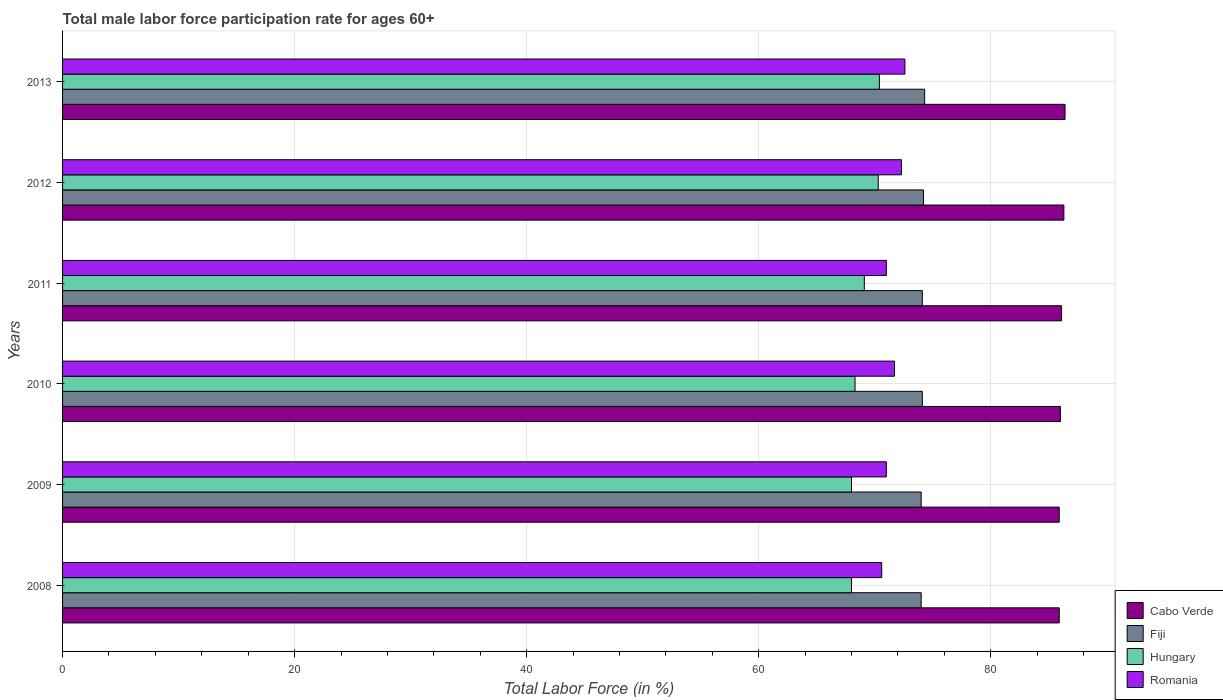How many groups of bars are there?
Make the answer very short. 6. Are the number of bars per tick equal to the number of legend labels?
Offer a terse response. Yes. Are the number of bars on each tick of the Y-axis equal?
Provide a short and direct response. Yes. How many bars are there on the 1st tick from the bottom?
Provide a short and direct response. 4. In how many cases, is the number of bars for a given year not equal to the number of legend labels?
Offer a very short reply. 0. What is the male labor force participation rate in Hungary in 2008?
Provide a succinct answer. 68. Across all years, what is the maximum male labor force participation rate in Fiji?
Provide a succinct answer. 74.3. In which year was the male labor force participation rate in Cabo Verde maximum?
Make the answer very short. 2013. What is the total male labor force participation rate in Cabo Verde in the graph?
Ensure brevity in your answer.  516.6. What is the difference between the male labor force participation rate in Fiji in 2009 and that in 2012?
Make the answer very short. -0.2. What is the difference between the male labor force participation rate in Romania in 2008 and the male labor force participation rate in Cabo Verde in 2013?
Provide a short and direct response. -15.8. What is the average male labor force participation rate in Cabo Verde per year?
Make the answer very short. 86.1. In the year 2010, what is the difference between the male labor force participation rate in Hungary and male labor force participation rate in Fiji?
Keep it short and to the point. -5.8. In how many years, is the male labor force participation rate in Cabo Verde greater than 16 %?
Provide a succinct answer. 6. What is the ratio of the male labor force participation rate in Hungary in 2009 to that in 2013?
Offer a terse response. 0.97. Is the difference between the male labor force participation rate in Hungary in 2010 and 2011 greater than the difference between the male labor force participation rate in Fiji in 2010 and 2011?
Give a very brief answer. No. What is the difference between the highest and the second highest male labor force participation rate in Cabo Verde?
Your answer should be very brief. 0.1. What does the 4th bar from the top in 2009 represents?
Your response must be concise. Cabo Verde. What does the 2nd bar from the bottom in 2010 represents?
Provide a short and direct response. Fiji. Is it the case that in every year, the sum of the male labor force participation rate in Romania and male labor force participation rate in Hungary is greater than the male labor force participation rate in Fiji?
Your response must be concise. Yes. How many bars are there?
Provide a succinct answer. 24. Are all the bars in the graph horizontal?
Your response must be concise. Yes. How many years are there in the graph?
Your answer should be very brief. 6. Are the values on the major ticks of X-axis written in scientific E-notation?
Provide a succinct answer. No. Does the graph contain grids?
Provide a succinct answer. Yes. Where does the legend appear in the graph?
Provide a succinct answer. Bottom right. How many legend labels are there?
Make the answer very short. 4. How are the legend labels stacked?
Your response must be concise. Vertical. What is the title of the graph?
Offer a terse response. Total male labor force participation rate for ages 60+. What is the label or title of the Y-axis?
Offer a very short reply. Years. What is the Total Labor Force (in %) of Cabo Verde in 2008?
Give a very brief answer. 85.9. What is the Total Labor Force (in %) in Fiji in 2008?
Offer a terse response. 74. What is the Total Labor Force (in %) in Romania in 2008?
Make the answer very short. 70.6. What is the Total Labor Force (in %) in Cabo Verde in 2009?
Give a very brief answer. 85.9. What is the Total Labor Force (in %) in Hungary in 2009?
Ensure brevity in your answer.  68. What is the Total Labor Force (in %) in Romania in 2009?
Your answer should be very brief. 71. What is the Total Labor Force (in %) of Fiji in 2010?
Provide a succinct answer. 74.1. What is the Total Labor Force (in %) of Hungary in 2010?
Give a very brief answer. 68.3. What is the Total Labor Force (in %) of Romania in 2010?
Your answer should be very brief. 71.7. What is the Total Labor Force (in %) in Cabo Verde in 2011?
Provide a short and direct response. 86.1. What is the Total Labor Force (in %) of Fiji in 2011?
Your answer should be very brief. 74.1. What is the Total Labor Force (in %) in Hungary in 2011?
Offer a very short reply. 69.1. What is the Total Labor Force (in %) in Romania in 2011?
Your response must be concise. 71. What is the Total Labor Force (in %) in Cabo Verde in 2012?
Provide a succinct answer. 86.3. What is the Total Labor Force (in %) in Fiji in 2012?
Provide a succinct answer. 74.2. What is the Total Labor Force (in %) in Hungary in 2012?
Keep it short and to the point. 70.3. What is the Total Labor Force (in %) of Romania in 2012?
Your answer should be compact. 72.3. What is the Total Labor Force (in %) in Cabo Verde in 2013?
Your response must be concise. 86.4. What is the Total Labor Force (in %) in Fiji in 2013?
Keep it short and to the point. 74.3. What is the Total Labor Force (in %) of Hungary in 2013?
Offer a very short reply. 70.4. What is the Total Labor Force (in %) of Romania in 2013?
Keep it short and to the point. 72.6. Across all years, what is the maximum Total Labor Force (in %) of Cabo Verde?
Provide a succinct answer. 86.4. Across all years, what is the maximum Total Labor Force (in %) in Fiji?
Offer a terse response. 74.3. Across all years, what is the maximum Total Labor Force (in %) in Hungary?
Offer a terse response. 70.4. Across all years, what is the maximum Total Labor Force (in %) of Romania?
Your response must be concise. 72.6. Across all years, what is the minimum Total Labor Force (in %) of Cabo Verde?
Offer a terse response. 85.9. Across all years, what is the minimum Total Labor Force (in %) in Romania?
Give a very brief answer. 70.6. What is the total Total Labor Force (in %) of Cabo Verde in the graph?
Keep it short and to the point. 516.6. What is the total Total Labor Force (in %) in Fiji in the graph?
Make the answer very short. 444.7. What is the total Total Labor Force (in %) in Hungary in the graph?
Provide a succinct answer. 414.1. What is the total Total Labor Force (in %) of Romania in the graph?
Your answer should be very brief. 429.2. What is the difference between the Total Labor Force (in %) in Cabo Verde in 2008 and that in 2009?
Offer a terse response. 0. What is the difference between the Total Labor Force (in %) in Hungary in 2008 and that in 2009?
Make the answer very short. 0. What is the difference between the Total Labor Force (in %) in Romania in 2008 and that in 2009?
Your response must be concise. -0.4. What is the difference between the Total Labor Force (in %) in Fiji in 2008 and that in 2010?
Your response must be concise. -0.1. What is the difference between the Total Labor Force (in %) of Hungary in 2008 and that in 2010?
Ensure brevity in your answer.  -0.3. What is the difference between the Total Labor Force (in %) of Romania in 2008 and that in 2011?
Keep it short and to the point. -0.4. What is the difference between the Total Labor Force (in %) in Cabo Verde in 2008 and that in 2012?
Your response must be concise. -0.4. What is the difference between the Total Labor Force (in %) in Fiji in 2008 and that in 2012?
Provide a succinct answer. -0.2. What is the difference between the Total Labor Force (in %) of Hungary in 2008 and that in 2012?
Your answer should be compact. -2.3. What is the difference between the Total Labor Force (in %) in Romania in 2008 and that in 2012?
Your response must be concise. -1.7. What is the difference between the Total Labor Force (in %) in Hungary in 2008 and that in 2013?
Give a very brief answer. -2.4. What is the difference between the Total Labor Force (in %) of Romania in 2008 and that in 2013?
Offer a very short reply. -2. What is the difference between the Total Labor Force (in %) of Romania in 2009 and that in 2010?
Your answer should be very brief. -0.7. What is the difference between the Total Labor Force (in %) in Cabo Verde in 2009 and that in 2011?
Provide a succinct answer. -0.2. What is the difference between the Total Labor Force (in %) of Fiji in 2009 and that in 2011?
Keep it short and to the point. -0.1. What is the difference between the Total Labor Force (in %) of Hungary in 2009 and that in 2011?
Provide a short and direct response. -1.1. What is the difference between the Total Labor Force (in %) in Hungary in 2009 and that in 2012?
Provide a short and direct response. -2.3. What is the difference between the Total Labor Force (in %) of Hungary in 2009 and that in 2013?
Your response must be concise. -2.4. What is the difference between the Total Labor Force (in %) of Romania in 2009 and that in 2013?
Your answer should be compact. -1.6. What is the difference between the Total Labor Force (in %) of Cabo Verde in 2010 and that in 2011?
Keep it short and to the point. -0.1. What is the difference between the Total Labor Force (in %) of Fiji in 2010 and that in 2011?
Keep it short and to the point. 0. What is the difference between the Total Labor Force (in %) of Hungary in 2010 and that in 2011?
Offer a terse response. -0.8. What is the difference between the Total Labor Force (in %) of Romania in 2010 and that in 2011?
Offer a terse response. 0.7. What is the difference between the Total Labor Force (in %) in Cabo Verde in 2010 and that in 2012?
Your response must be concise. -0.3. What is the difference between the Total Labor Force (in %) of Hungary in 2010 and that in 2012?
Provide a short and direct response. -2. What is the difference between the Total Labor Force (in %) of Hungary in 2010 and that in 2013?
Ensure brevity in your answer.  -2.1. What is the difference between the Total Labor Force (in %) in Romania in 2010 and that in 2013?
Your answer should be compact. -0.9. What is the difference between the Total Labor Force (in %) in Cabo Verde in 2011 and that in 2012?
Your answer should be compact. -0.2. What is the difference between the Total Labor Force (in %) in Fiji in 2011 and that in 2012?
Make the answer very short. -0.1. What is the difference between the Total Labor Force (in %) of Hungary in 2011 and that in 2012?
Your response must be concise. -1.2. What is the difference between the Total Labor Force (in %) in Romania in 2011 and that in 2012?
Provide a short and direct response. -1.3. What is the difference between the Total Labor Force (in %) in Cabo Verde in 2011 and that in 2013?
Keep it short and to the point. -0.3. What is the difference between the Total Labor Force (in %) in Fiji in 2011 and that in 2013?
Offer a terse response. -0.2. What is the difference between the Total Labor Force (in %) in Hungary in 2011 and that in 2013?
Ensure brevity in your answer.  -1.3. What is the difference between the Total Labor Force (in %) of Cabo Verde in 2012 and that in 2013?
Offer a very short reply. -0.1. What is the difference between the Total Labor Force (in %) in Fiji in 2012 and that in 2013?
Keep it short and to the point. -0.1. What is the difference between the Total Labor Force (in %) of Cabo Verde in 2008 and the Total Labor Force (in %) of Romania in 2009?
Provide a succinct answer. 14.9. What is the difference between the Total Labor Force (in %) of Fiji in 2008 and the Total Labor Force (in %) of Romania in 2009?
Your response must be concise. 3. What is the difference between the Total Labor Force (in %) of Cabo Verde in 2008 and the Total Labor Force (in %) of Fiji in 2010?
Your response must be concise. 11.8. What is the difference between the Total Labor Force (in %) of Cabo Verde in 2008 and the Total Labor Force (in %) of Hungary in 2010?
Give a very brief answer. 17.6. What is the difference between the Total Labor Force (in %) in Cabo Verde in 2008 and the Total Labor Force (in %) in Romania in 2010?
Your answer should be very brief. 14.2. What is the difference between the Total Labor Force (in %) in Fiji in 2008 and the Total Labor Force (in %) in Romania in 2010?
Your answer should be very brief. 2.3. What is the difference between the Total Labor Force (in %) of Cabo Verde in 2008 and the Total Labor Force (in %) of Fiji in 2011?
Your response must be concise. 11.8. What is the difference between the Total Labor Force (in %) of Cabo Verde in 2008 and the Total Labor Force (in %) of Fiji in 2012?
Your answer should be very brief. 11.7. What is the difference between the Total Labor Force (in %) of Fiji in 2008 and the Total Labor Force (in %) of Hungary in 2012?
Offer a very short reply. 3.7. What is the difference between the Total Labor Force (in %) in Hungary in 2008 and the Total Labor Force (in %) in Romania in 2012?
Give a very brief answer. -4.3. What is the difference between the Total Labor Force (in %) of Cabo Verde in 2008 and the Total Labor Force (in %) of Hungary in 2013?
Give a very brief answer. 15.5. What is the difference between the Total Labor Force (in %) in Cabo Verde in 2008 and the Total Labor Force (in %) in Romania in 2013?
Your response must be concise. 13.3. What is the difference between the Total Labor Force (in %) of Fiji in 2008 and the Total Labor Force (in %) of Hungary in 2013?
Provide a succinct answer. 3.6. What is the difference between the Total Labor Force (in %) in Cabo Verde in 2009 and the Total Labor Force (in %) in Hungary in 2010?
Your answer should be compact. 17.6. What is the difference between the Total Labor Force (in %) of Cabo Verde in 2009 and the Total Labor Force (in %) of Romania in 2010?
Your answer should be compact. 14.2. What is the difference between the Total Labor Force (in %) in Cabo Verde in 2009 and the Total Labor Force (in %) in Fiji in 2011?
Give a very brief answer. 11.8. What is the difference between the Total Labor Force (in %) in Cabo Verde in 2009 and the Total Labor Force (in %) in Hungary in 2011?
Your answer should be compact. 16.8. What is the difference between the Total Labor Force (in %) in Fiji in 2009 and the Total Labor Force (in %) in Hungary in 2011?
Your answer should be very brief. 4.9. What is the difference between the Total Labor Force (in %) in Fiji in 2009 and the Total Labor Force (in %) in Romania in 2011?
Make the answer very short. 3. What is the difference between the Total Labor Force (in %) of Cabo Verde in 2009 and the Total Labor Force (in %) of Hungary in 2012?
Offer a terse response. 15.6. What is the difference between the Total Labor Force (in %) in Cabo Verde in 2009 and the Total Labor Force (in %) in Romania in 2012?
Make the answer very short. 13.6. What is the difference between the Total Labor Force (in %) of Fiji in 2009 and the Total Labor Force (in %) of Hungary in 2012?
Your response must be concise. 3.7. What is the difference between the Total Labor Force (in %) of Fiji in 2009 and the Total Labor Force (in %) of Romania in 2012?
Give a very brief answer. 1.7. What is the difference between the Total Labor Force (in %) in Cabo Verde in 2009 and the Total Labor Force (in %) in Fiji in 2013?
Provide a short and direct response. 11.6. What is the difference between the Total Labor Force (in %) of Cabo Verde in 2009 and the Total Labor Force (in %) of Hungary in 2013?
Provide a short and direct response. 15.5. What is the difference between the Total Labor Force (in %) in Fiji in 2009 and the Total Labor Force (in %) in Hungary in 2013?
Make the answer very short. 3.6. What is the difference between the Total Labor Force (in %) of Fiji in 2009 and the Total Labor Force (in %) of Romania in 2013?
Your answer should be very brief. 1.4. What is the difference between the Total Labor Force (in %) of Hungary in 2009 and the Total Labor Force (in %) of Romania in 2013?
Offer a terse response. -4.6. What is the difference between the Total Labor Force (in %) in Cabo Verde in 2010 and the Total Labor Force (in %) in Fiji in 2011?
Ensure brevity in your answer.  11.9. What is the difference between the Total Labor Force (in %) of Cabo Verde in 2010 and the Total Labor Force (in %) of Hungary in 2011?
Keep it short and to the point. 16.9. What is the difference between the Total Labor Force (in %) of Fiji in 2010 and the Total Labor Force (in %) of Romania in 2011?
Offer a terse response. 3.1. What is the difference between the Total Labor Force (in %) of Hungary in 2010 and the Total Labor Force (in %) of Romania in 2011?
Offer a very short reply. -2.7. What is the difference between the Total Labor Force (in %) in Cabo Verde in 2010 and the Total Labor Force (in %) in Fiji in 2012?
Keep it short and to the point. 11.8. What is the difference between the Total Labor Force (in %) of Fiji in 2010 and the Total Labor Force (in %) of Romania in 2012?
Make the answer very short. 1.8. What is the difference between the Total Labor Force (in %) of Hungary in 2010 and the Total Labor Force (in %) of Romania in 2013?
Offer a very short reply. -4.3. What is the difference between the Total Labor Force (in %) in Fiji in 2011 and the Total Labor Force (in %) in Hungary in 2012?
Make the answer very short. 3.8. What is the difference between the Total Labor Force (in %) of Fiji in 2011 and the Total Labor Force (in %) of Romania in 2012?
Your answer should be very brief. 1.8. What is the difference between the Total Labor Force (in %) of Hungary in 2011 and the Total Labor Force (in %) of Romania in 2012?
Give a very brief answer. -3.2. What is the difference between the Total Labor Force (in %) in Cabo Verde in 2011 and the Total Labor Force (in %) in Fiji in 2013?
Your answer should be compact. 11.8. What is the difference between the Total Labor Force (in %) of Cabo Verde in 2011 and the Total Labor Force (in %) of Romania in 2013?
Your answer should be compact. 13.5. What is the difference between the Total Labor Force (in %) of Cabo Verde in 2012 and the Total Labor Force (in %) of Fiji in 2013?
Offer a very short reply. 12. What is the difference between the Total Labor Force (in %) of Cabo Verde in 2012 and the Total Labor Force (in %) of Hungary in 2013?
Your answer should be compact. 15.9. What is the difference between the Total Labor Force (in %) of Fiji in 2012 and the Total Labor Force (in %) of Hungary in 2013?
Offer a very short reply. 3.8. What is the difference between the Total Labor Force (in %) of Fiji in 2012 and the Total Labor Force (in %) of Romania in 2013?
Make the answer very short. 1.6. What is the average Total Labor Force (in %) of Cabo Verde per year?
Your answer should be very brief. 86.1. What is the average Total Labor Force (in %) of Fiji per year?
Offer a terse response. 74.12. What is the average Total Labor Force (in %) of Hungary per year?
Your answer should be very brief. 69.02. What is the average Total Labor Force (in %) in Romania per year?
Ensure brevity in your answer.  71.53. In the year 2008, what is the difference between the Total Labor Force (in %) in Cabo Verde and Total Labor Force (in %) in Hungary?
Provide a short and direct response. 17.9. In the year 2008, what is the difference between the Total Labor Force (in %) of Fiji and Total Labor Force (in %) of Romania?
Your response must be concise. 3.4. In the year 2009, what is the difference between the Total Labor Force (in %) of Cabo Verde and Total Labor Force (in %) of Fiji?
Give a very brief answer. 11.9. In the year 2009, what is the difference between the Total Labor Force (in %) of Cabo Verde and Total Labor Force (in %) of Hungary?
Offer a terse response. 17.9. In the year 2009, what is the difference between the Total Labor Force (in %) in Hungary and Total Labor Force (in %) in Romania?
Offer a terse response. -3. In the year 2010, what is the difference between the Total Labor Force (in %) of Fiji and Total Labor Force (in %) of Hungary?
Give a very brief answer. 5.8. In the year 2010, what is the difference between the Total Labor Force (in %) of Fiji and Total Labor Force (in %) of Romania?
Your answer should be very brief. 2.4. In the year 2011, what is the difference between the Total Labor Force (in %) of Cabo Verde and Total Labor Force (in %) of Hungary?
Your answer should be compact. 17. In the year 2011, what is the difference between the Total Labor Force (in %) of Cabo Verde and Total Labor Force (in %) of Romania?
Keep it short and to the point. 15.1. In the year 2011, what is the difference between the Total Labor Force (in %) of Fiji and Total Labor Force (in %) of Hungary?
Make the answer very short. 5. In the year 2011, what is the difference between the Total Labor Force (in %) in Hungary and Total Labor Force (in %) in Romania?
Your answer should be very brief. -1.9. In the year 2012, what is the difference between the Total Labor Force (in %) in Cabo Verde and Total Labor Force (in %) in Fiji?
Your response must be concise. 12.1. In the year 2012, what is the difference between the Total Labor Force (in %) in Cabo Verde and Total Labor Force (in %) in Romania?
Make the answer very short. 14. In the year 2012, what is the difference between the Total Labor Force (in %) of Fiji and Total Labor Force (in %) of Hungary?
Give a very brief answer. 3.9. In the year 2012, what is the difference between the Total Labor Force (in %) of Fiji and Total Labor Force (in %) of Romania?
Give a very brief answer. 1.9. In the year 2012, what is the difference between the Total Labor Force (in %) in Hungary and Total Labor Force (in %) in Romania?
Provide a succinct answer. -2. In the year 2013, what is the difference between the Total Labor Force (in %) of Cabo Verde and Total Labor Force (in %) of Romania?
Make the answer very short. 13.8. In the year 2013, what is the difference between the Total Labor Force (in %) of Fiji and Total Labor Force (in %) of Hungary?
Make the answer very short. 3.9. In the year 2013, what is the difference between the Total Labor Force (in %) of Fiji and Total Labor Force (in %) of Romania?
Offer a terse response. 1.7. What is the ratio of the Total Labor Force (in %) in Cabo Verde in 2008 to that in 2009?
Your answer should be very brief. 1. What is the ratio of the Total Labor Force (in %) of Fiji in 2008 to that in 2009?
Give a very brief answer. 1. What is the ratio of the Total Labor Force (in %) of Romania in 2008 to that in 2009?
Offer a terse response. 0.99. What is the ratio of the Total Labor Force (in %) in Cabo Verde in 2008 to that in 2010?
Your answer should be compact. 1. What is the ratio of the Total Labor Force (in %) in Fiji in 2008 to that in 2010?
Provide a succinct answer. 1. What is the ratio of the Total Labor Force (in %) of Romania in 2008 to that in 2010?
Provide a succinct answer. 0.98. What is the ratio of the Total Labor Force (in %) in Cabo Verde in 2008 to that in 2011?
Your answer should be very brief. 1. What is the ratio of the Total Labor Force (in %) of Fiji in 2008 to that in 2011?
Give a very brief answer. 1. What is the ratio of the Total Labor Force (in %) in Hungary in 2008 to that in 2011?
Your answer should be compact. 0.98. What is the ratio of the Total Labor Force (in %) of Romania in 2008 to that in 2011?
Offer a terse response. 0.99. What is the ratio of the Total Labor Force (in %) in Hungary in 2008 to that in 2012?
Your answer should be compact. 0.97. What is the ratio of the Total Labor Force (in %) in Romania in 2008 to that in 2012?
Keep it short and to the point. 0.98. What is the ratio of the Total Labor Force (in %) of Cabo Verde in 2008 to that in 2013?
Keep it short and to the point. 0.99. What is the ratio of the Total Labor Force (in %) in Hungary in 2008 to that in 2013?
Your answer should be compact. 0.97. What is the ratio of the Total Labor Force (in %) in Romania in 2008 to that in 2013?
Your response must be concise. 0.97. What is the ratio of the Total Labor Force (in %) in Cabo Verde in 2009 to that in 2010?
Your answer should be very brief. 1. What is the ratio of the Total Labor Force (in %) in Hungary in 2009 to that in 2010?
Your response must be concise. 1. What is the ratio of the Total Labor Force (in %) in Romania in 2009 to that in 2010?
Offer a terse response. 0.99. What is the ratio of the Total Labor Force (in %) in Cabo Verde in 2009 to that in 2011?
Your response must be concise. 1. What is the ratio of the Total Labor Force (in %) in Hungary in 2009 to that in 2011?
Offer a terse response. 0.98. What is the ratio of the Total Labor Force (in %) of Romania in 2009 to that in 2011?
Your answer should be compact. 1. What is the ratio of the Total Labor Force (in %) of Cabo Verde in 2009 to that in 2012?
Make the answer very short. 1. What is the ratio of the Total Labor Force (in %) of Hungary in 2009 to that in 2012?
Your response must be concise. 0.97. What is the ratio of the Total Labor Force (in %) of Romania in 2009 to that in 2012?
Your response must be concise. 0.98. What is the ratio of the Total Labor Force (in %) of Cabo Verde in 2009 to that in 2013?
Keep it short and to the point. 0.99. What is the ratio of the Total Labor Force (in %) in Hungary in 2009 to that in 2013?
Offer a terse response. 0.97. What is the ratio of the Total Labor Force (in %) of Romania in 2009 to that in 2013?
Make the answer very short. 0.98. What is the ratio of the Total Labor Force (in %) in Hungary in 2010 to that in 2011?
Offer a very short reply. 0.99. What is the ratio of the Total Labor Force (in %) in Romania in 2010 to that in 2011?
Give a very brief answer. 1.01. What is the ratio of the Total Labor Force (in %) of Hungary in 2010 to that in 2012?
Provide a succinct answer. 0.97. What is the ratio of the Total Labor Force (in %) in Romania in 2010 to that in 2012?
Provide a short and direct response. 0.99. What is the ratio of the Total Labor Force (in %) of Cabo Verde in 2010 to that in 2013?
Keep it short and to the point. 1. What is the ratio of the Total Labor Force (in %) of Hungary in 2010 to that in 2013?
Your answer should be very brief. 0.97. What is the ratio of the Total Labor Force (in %) in Romania in 2010 to that in 2013?
Offer a terse response. 0.99. What is the ratio of the Total Labor Force (in %) in Fiji in 2011 to that in 2012?
Give a very brief answer. 1. What is the ratio of the Total Labor Force (in %) in Hungary in 2011 to that in 2012?
Offer a very short reply. 0.98. What is the ratio of the Total Labor Force (in %) in Romania in 2011 to that in 2012?
Keep it short and to the point. 0.98. What is the ratio of the Total Labor Force (in %) of Hungary in 2011 to that in 2013?
Your answer should be very brief. 0.98. What is the ratio of the Total Labor Force (in %) of Romania in 2011 to that in 2013?
Make the answer very short. 0.98. What is the ratio of the Total Labor Force (in %) in Romania in 2012 to that in 2013?
Give a very brief answer. 1. What is the difference between the highest and the second highest Total Labor Force (in %) of Fiji?
Your answer should be compact. 0.1. What is the difference between the highest and the second highest Total Labor Force (in %) in Romania?
Make the answer very short. 0.3. What is the difference between the highest and the lowest Total Labor Force (in %) of Hungary?
Provide a succinct answer. 2.4. What is the difference between the highest and the lowest Total Labor Force (in %) of Romania?
Your response must be concise. 2. 